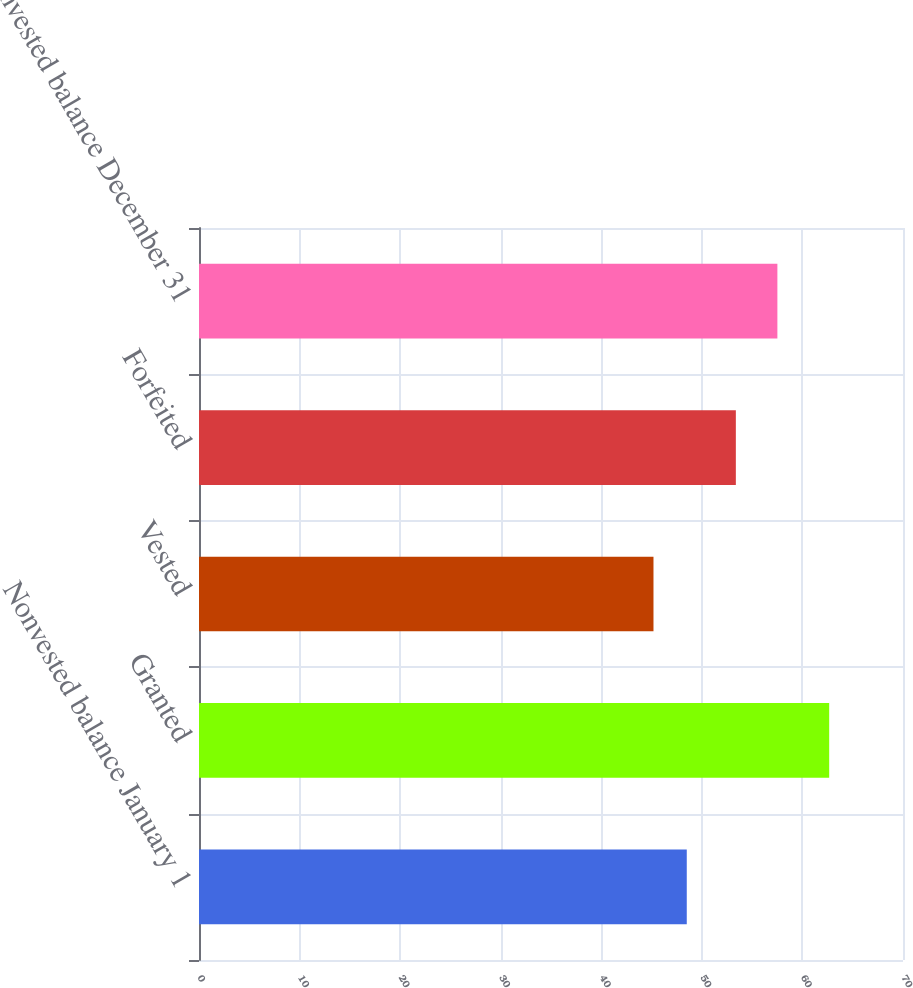Convert chart. <chart><loc_0><loc_0><loc_500><loc_500><bar_chart><fcel>Nonvested balance January 1<fcel>Granted<fcel>Vested<fcel>Forfeited<fcel>Nonvested balance December 31<nl><fcel>48.5<fcel>62.66<fcel>45.19<fcel>53.38<fcel>57.51<nl></chart> 